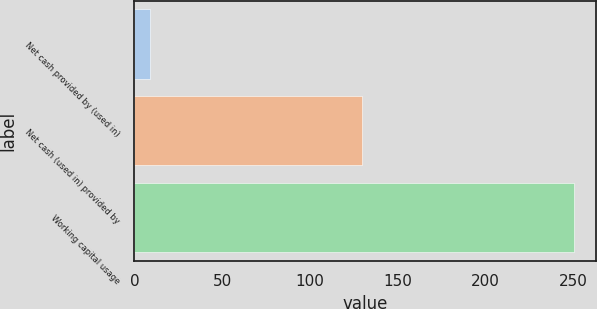<chart> <loc_0><loc_0><loc_500><loc_500><bar_chart><fcel>Net cash provided by (used in)<fcel>Net cash (used in) provided by<fcel>Working capital usage<nl><fcel>9<fcel>129.7<fcel>250.6<nl></chart> 